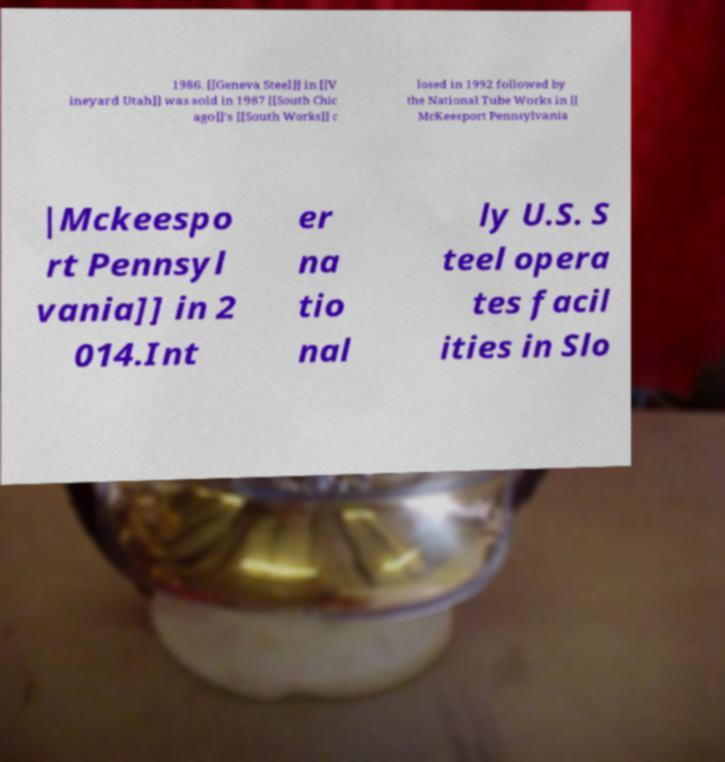Could you assist in decoding the text presented in this image and type it out clearly? 1986. [[Geneva Steel]] in [[V ineyard Utah]] was sold in 1987 [[South Chic ago]]'s [[South Works]] c losed in 1992 followed by the National Tube Works in [[ McKeesport Pennsylvania |Mckeespo rt Pennsyl vania]] in 2 014.Int er na tio nal ly U.S. S teel opera tes facil ities in Slo 